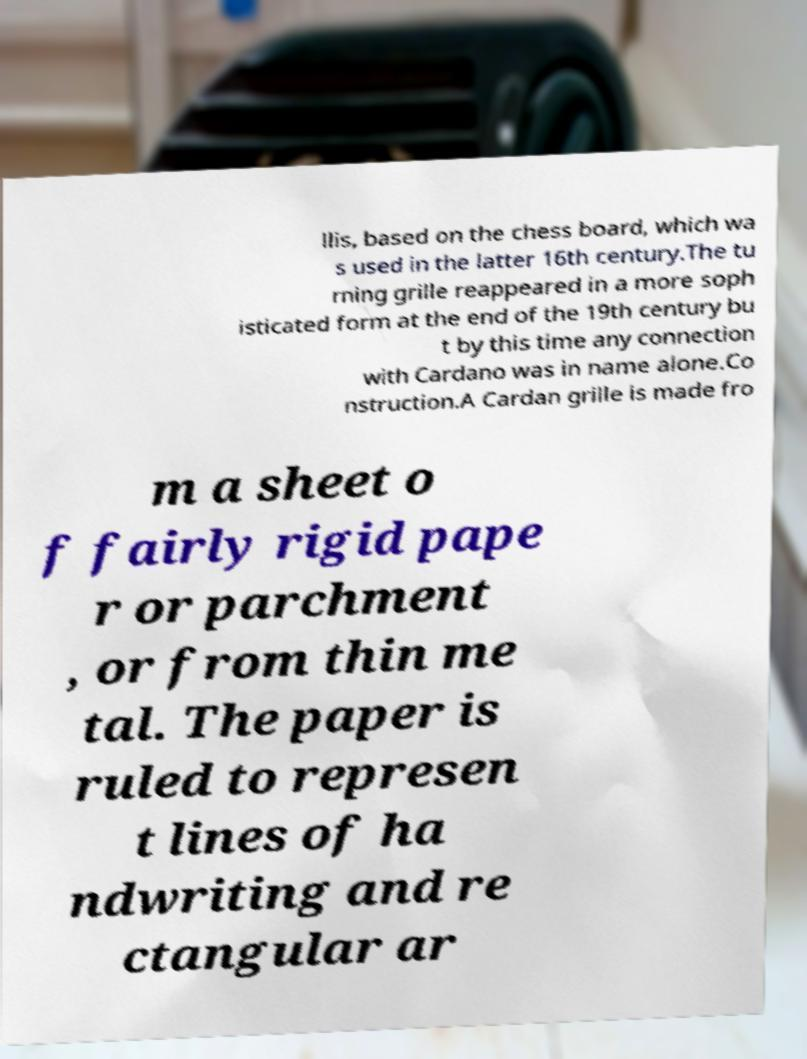What messages or text are displayed in this image? I need them in a readable, typed format. llis, based on the chess board, which wa s used in the latter 16th century.The tu rning grille reappeared in a more soph isticated form at the end of the 19th century bu t by this time any connection with Cardano was in name alone.Co nstruction.A Cardan grille is made fro m a sheet o f fairly rigid pape r or parchment , or from thin me tal. The paper is ruled to represen t lines of ha ndwriting and re ctangular ar 